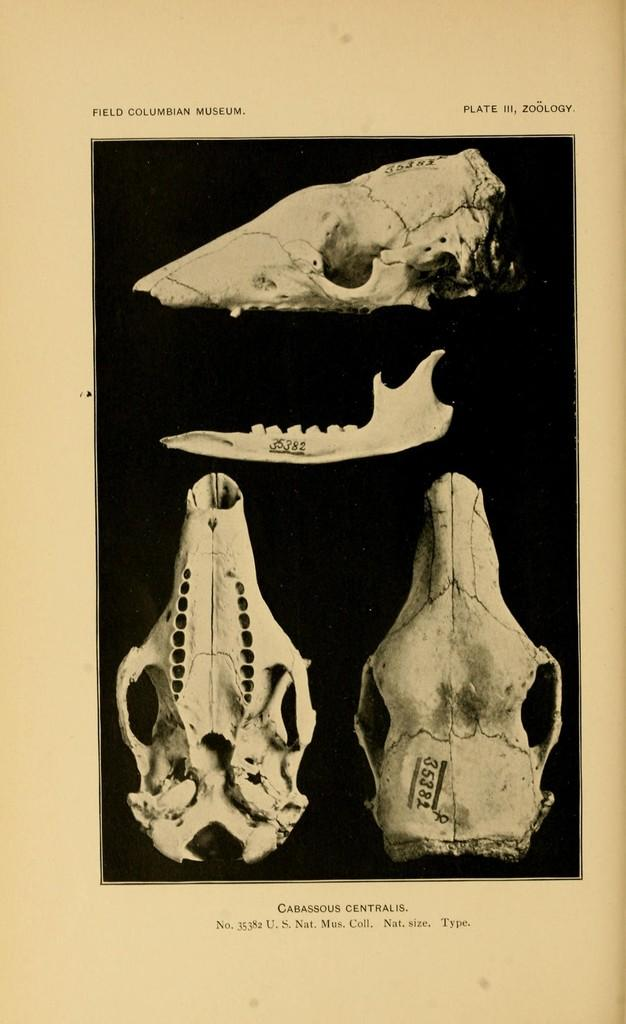What is the main subject of the image? The main subject of the image is a poster. What is depicted on the poster? The poster contains different types of bones. Where can text be found on the poster? There is text at the top and bottom of the poster. What type of truck is shown in the image? There is no truck present in the image; it features a poster with different types of bones. Can you tell me how many drawers are visible in the image? There are no drawers present in the image; it features a poster with different types of bones. 